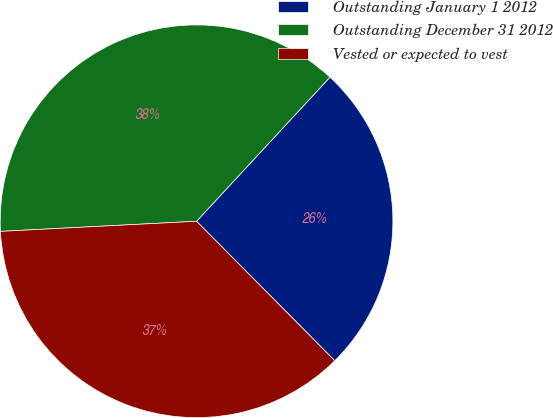Convert chart to OTSL. <chart><loc_0><loc_0><loc_500><loc_500><pie_chart><fcel>Outstanding January 1 2012<fcel>Outstanding December 31 2012<fcel>Vested or expected to vest<nl><fcel>25.68%<fcel>37.71%<fcel>36.61%<nl></chart> 